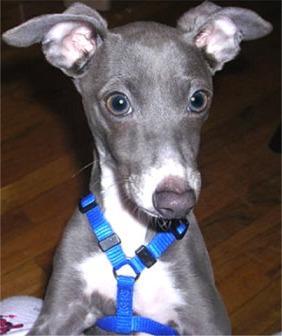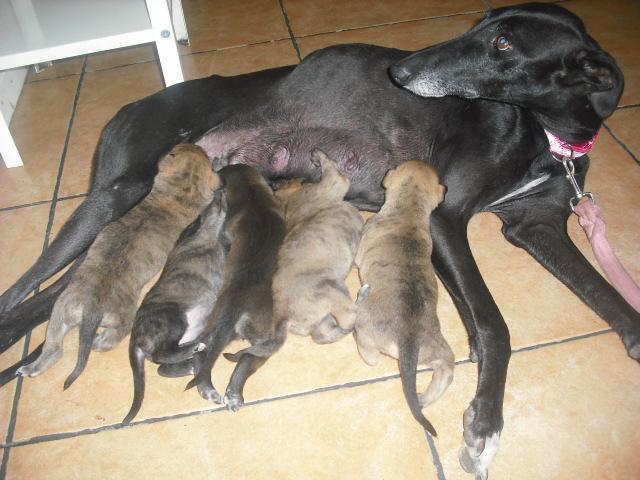The first image is the image on the left, the second image is the image on the right. For the images shown, is this caption "None of the dogs are wearing collars." true? Answer yes or no. No. The first image is the image on the left, the second image is the image on the right. Given the left and right images, does the statement "There are at least four gray and white puppies." hold true? Answer yes or no. No. 